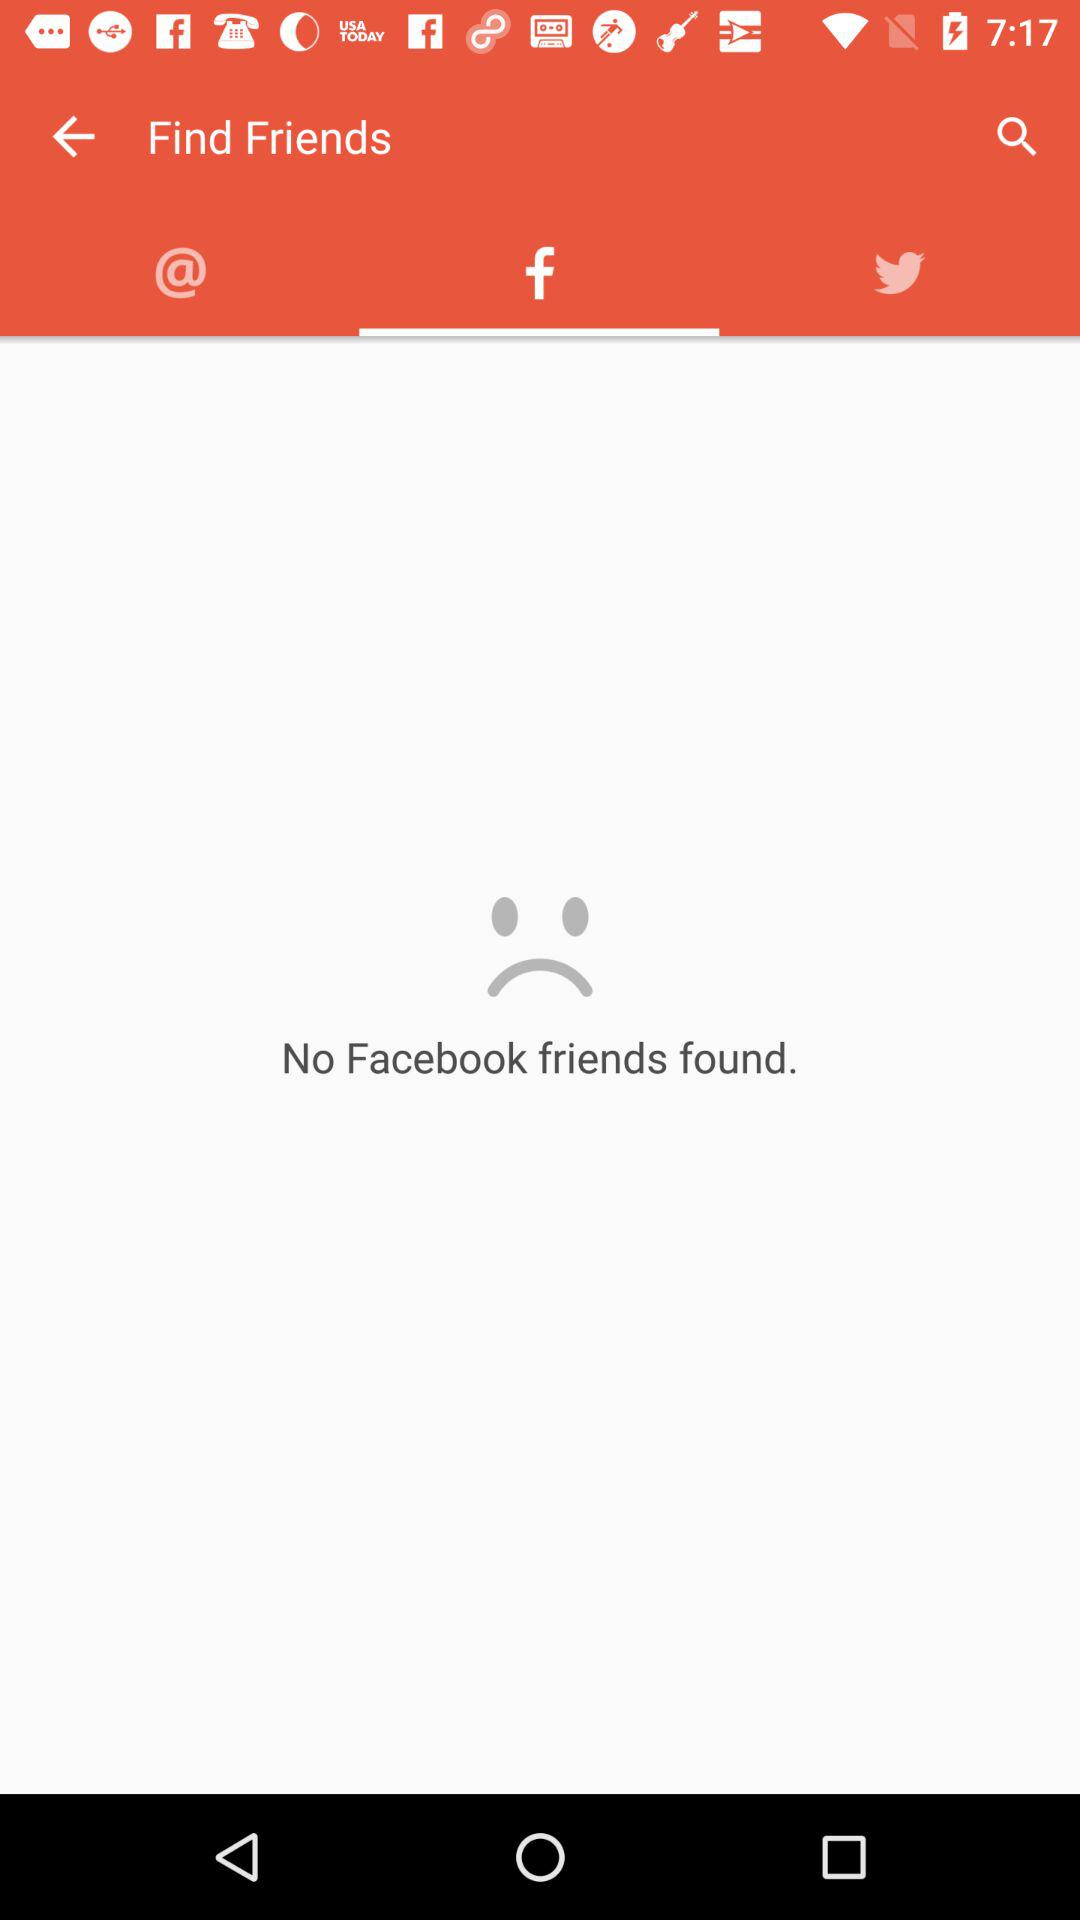Which tab is selected? The selected tab is "Facebook". 